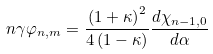<formula> <loc_0><loc_0><loc_500><loc_500>n \gamma \varphi _ { n , m } = \frac { \left ( { 1 + \kappa } \right ) ^ { 2 } } { 4 \left ( { 1 - \kappa } \right ) } \frac { d \chi _ { n - 1 , 0 } } { d \alpha }</formula> 